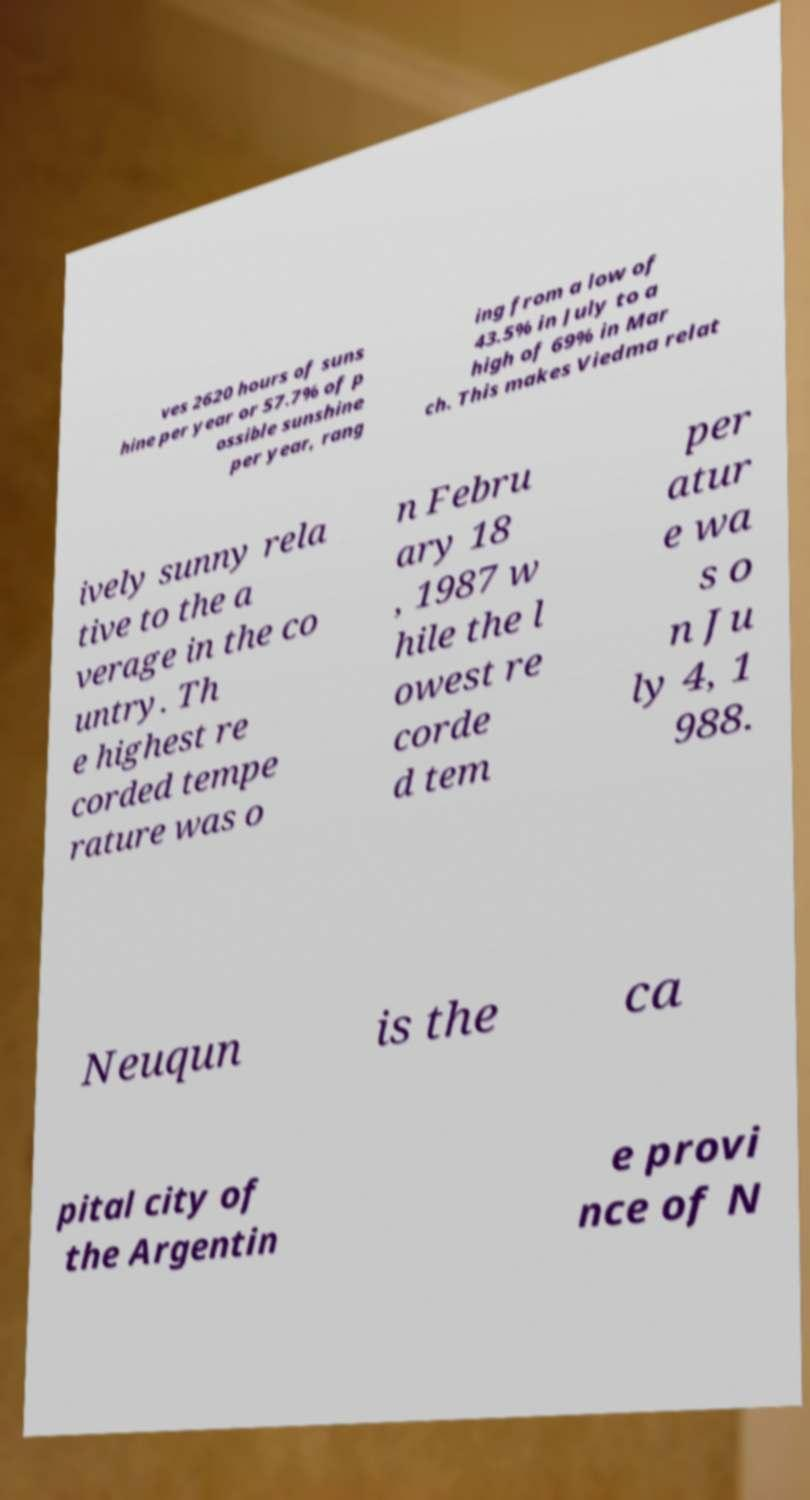Could you extract and type out the text from this image? ves 2620 hours of suns hine per year or 57.7% of p ossible sunshine per year, rang ing from a low of 43.5% in July to a high of 69% in Mar ch. This makes Viedma relat ively sunny rela tive to the a verage in the co untry. Th e highest re corded tempe rature was o n Febru ary 18 , 1987 w hile the l owest re corde d tem per atur e wa s o n Ju ly 4, 1 988. Neuqun is the ca pital city of the Argentin e provi nce of N 